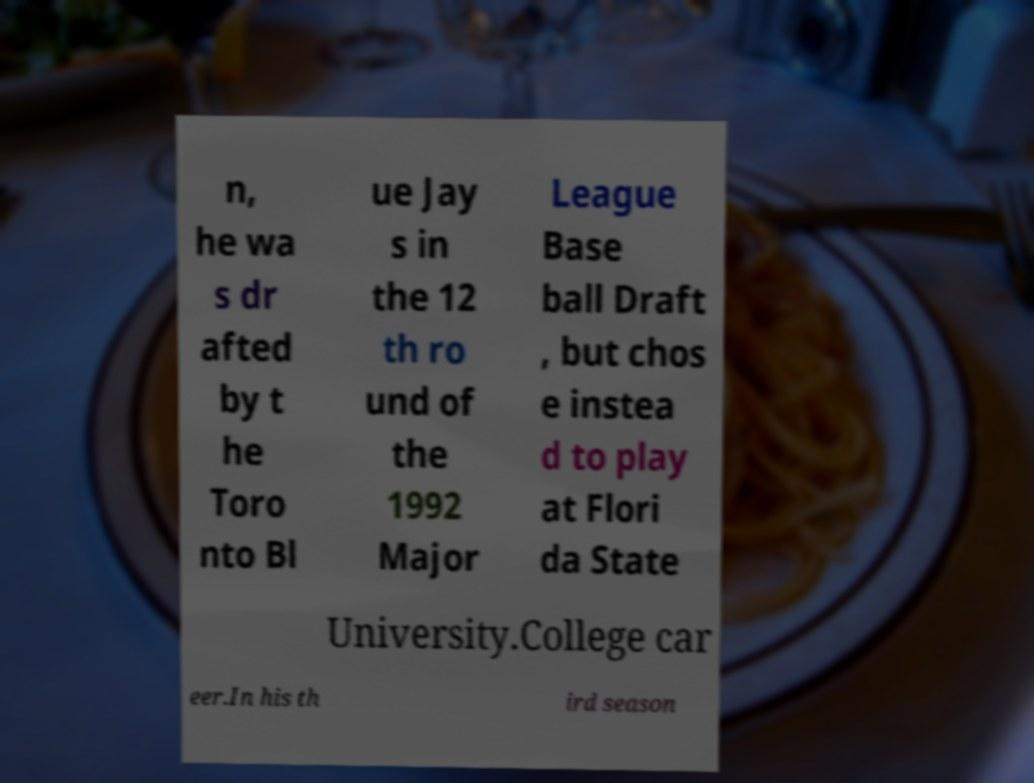Could you extract and type out the text from this image? n, he wa s dr afted by t he Toro nto Bl ue Jay s in the 12 th ro und of the 1992 Major League Base ball Draft , but chos e instea d to play at Flori da State University.College car eer.In his th ird season 